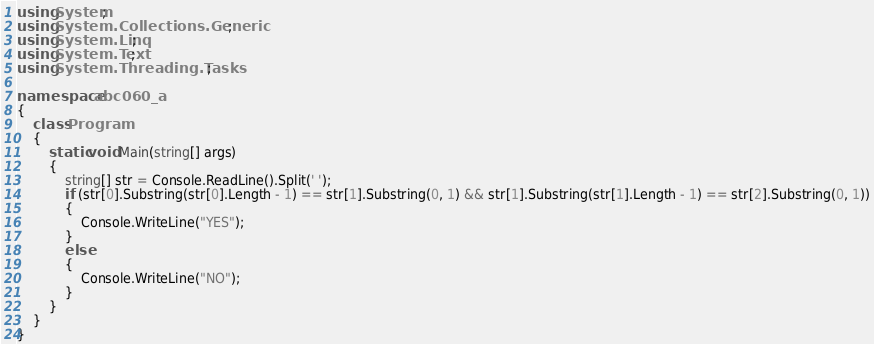<code> <loc_0><loc_0><loc_500><loc_500><_C#_>using System;
using System.Collections.Generic;
using System.Linq;
using System.Text;
using System.Threading.Tasks;

namespace abc060_a
{
    class Program
    {
        static void Main(string[] args)
        {
            string[] str = Console.ReadLine().Split(' ');
            if (str[0].Substring(str[0].Length - 1) == str[1].Substring(0, 1) && str[1].Substring(str[1].Length - 1) == str[2].Substring(0, 1))
            {
                Console.WriteLine("YES");
            }
            else
            {
                Console.WriteLine("NO");
            }
        }
    }
}
</code> 